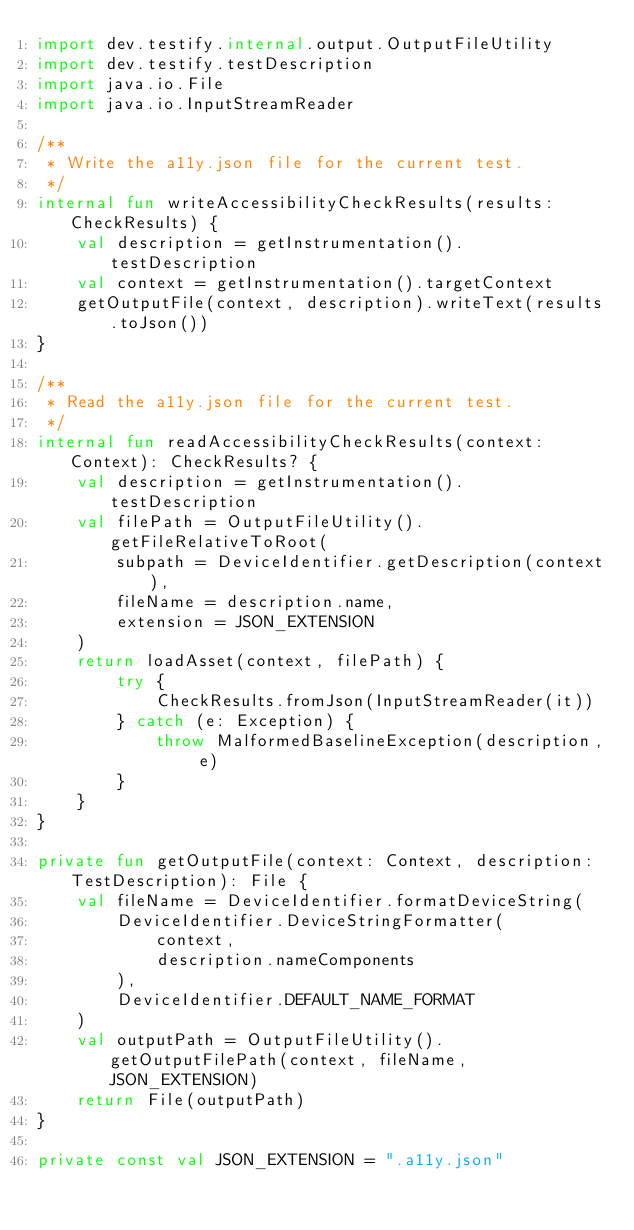<code> <loc_0><loc_0><loc_500><loc_500><_Kotlin_>import dev.testify.internal.output.OutputFileUtility
import dev.testify.testDescription
import java.io.File
import java.io.InputStreamReader

/**
 * Write the a11y.json file for the current test.
 */
internal fun writeAccessibilityCheckResults(results: CheckResults) {
    val description = getInstrumentation().testDescription
    val context = getInstrumentation().targetContext
    getOutputFile(context, description).writeText(results.toJson())
}

/**
 * Read the a11y.json file for the current test.
 */
internal fun readAccessibilityCheckResults(context: Context): CheckResults? {
    val description = getInstrumentation().testDescription
    val filePath = OutputFileUtility().getFileRelativeToRoot(
        subpath = DeviceIdentifier.getDescription(context),
        fileName = description.name,
        extension = JSON_EXTENSION
    )
    return loadAsset(context, filePath) {
        try {
            CheckResults.fromJson(InputStreamReader(it))
        } catch (e: Exception) {
            throw MalformedBaselineException(description, e)
        }
    }
}

private fun getOutputFile(context: Context, description: TestDescription): File {
    val fileName = DeviceIdentifier.formatDeviceString(
        DeviceIdentifier.DeviceStringFormatter(
            context,
            description.nameComponents
        ),
        DeviceIdentifier.DEFAULT_NAME_FORMAT
    )
    val outputPath = OutputFileUtility().getOutputFilePath(context, fileName, JSON_EXTENSION)
    return File(outputPath)
}

private const val JSON_EXTENSION = ".a11y.json"
</code> 